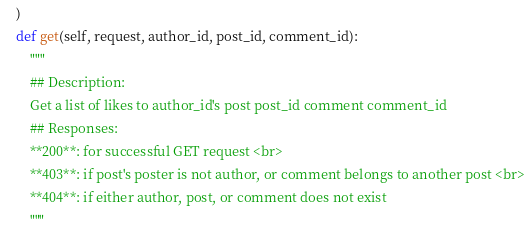<code> <loc_0><loc_0><loc_500><loc_500><_Python_>    )
    def get(self, request, author_id, post_id, comment_id):
        """
        ## Description:
        Get a list of likes to author_id's post post_id comment comment_id
        ## Responses:
        **200**: for successful GET request <br>
        **403**: if post's poster is not author, or comment belongs to another post <br>
        **404**: if either author, post, or comment does not exist
        """</code> 